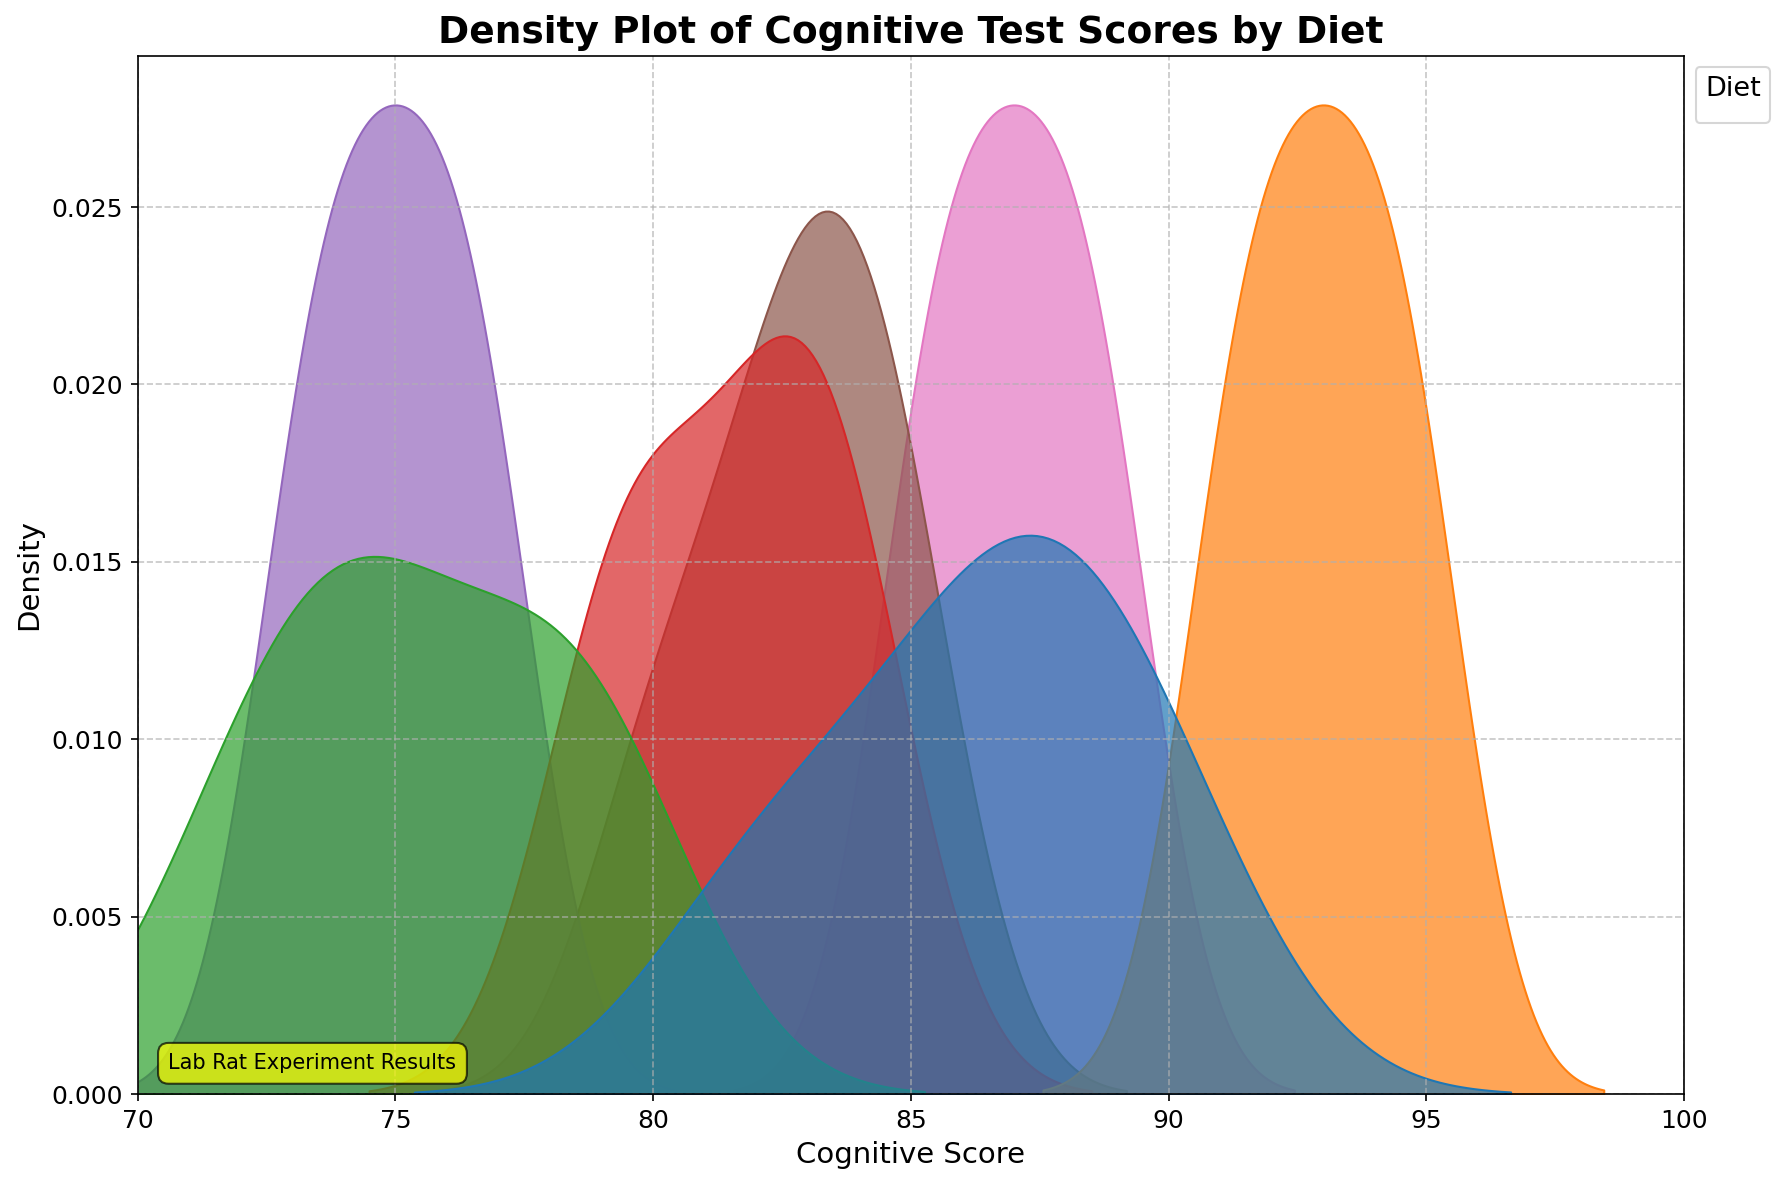What is the title of the density plot? The title is displayed at the top of the plot in bold text. It states the main subject of the plot.
Answer: Density Plot of Cognitive Test Scores by Diet What is the x-axis label? The x-axis label is displayed below the horizontal axis, and it indicates the variable plotted on this axis.
Answer: Cognitive Score Which diet group appears to have the highest density peak? By observing the height of the peaks in the plot, we can identify which group's curve reaches the highest point.
Answer: High_Protein Between High_Fat and Low_Fat, which diet shows a lower peak density for Cognitive Scores? Look at the maximum height of the density curves for High_Fat and Low_Fat and compare them.
Answer: Low_Fat Where is the density peak for the Low_Protein diet? Examine the plot to see where the curve for Low_Protein reaches its highest value along the Cognitive Score axis.
Answer: Around 75 Which diet groups show overlapping density curves? Assess the plot to identify where density curves of different diet groups overlap.
Answer: Control, High_Carb, Low_Carb Based on the density curves, which diet likely results in the highest Cognitive Scores? The highest Cognitive Scores are indicated by the curve that extends furthest to the right on the x-axis.
Answer: High_Protein What is the cognitive score range shown in the plot? The cognitive score range can be identified from the limits set on the x-axis.
Answer: 70 to 100 Which diet shows the least variability in Cognitive Scores? The diet with the least variability will have the narrowest peak in its density plot.
Answer: High_Protein What common Cognitive Score range do most diets seem to share? By observing where multiple density curves overlap significantly on the x-axis, we can determine a common range.
Answer: 80 to 85 